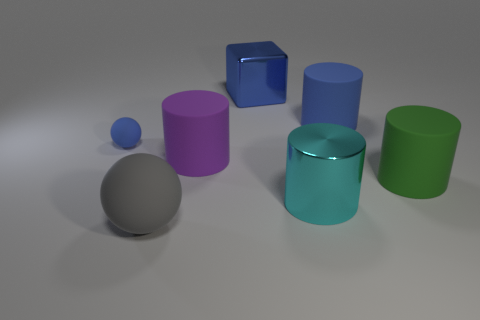Does the big blue metallic object have the same shape as the big metal object that is in front of the big blue metallic object?
Your answer should be very brief. No. How many other objects are there of the same size as the blue rubber sphere?
Keep it short and to the point. 0. Are there more big green matte things than small red matte balls?
Ensure brevity in your answer.  Yes. How many big things are both to the right of the large blue rubber cylinder and left of the metal cube?
Provide a succinct answer. 0. There is a large matte object that is behind the object on the left side of the rubber sphere that is in front of the blue matte ball; what shape is it?
Keep it short and to the point. Cylinder. Is there any other thing that is the same shape as the large green thing?
Keep it short and to the point. Yes. What number of cylinders are green matte things or small blue matte objects?
Your answer should be compact. 1. Do the big shiny thing behind the small blue object and the small thing have the same color?
Ensure brevity in your answer.  Yes. What is the large cylinder that is behind the blue matte object left of the matte cylinder that is left of the cyan metal thing made of?
Ensure brevity in your answer.  Rubber. Do the gray sphere and the blue ball have the same size?
Your answer should be very brief. No. 